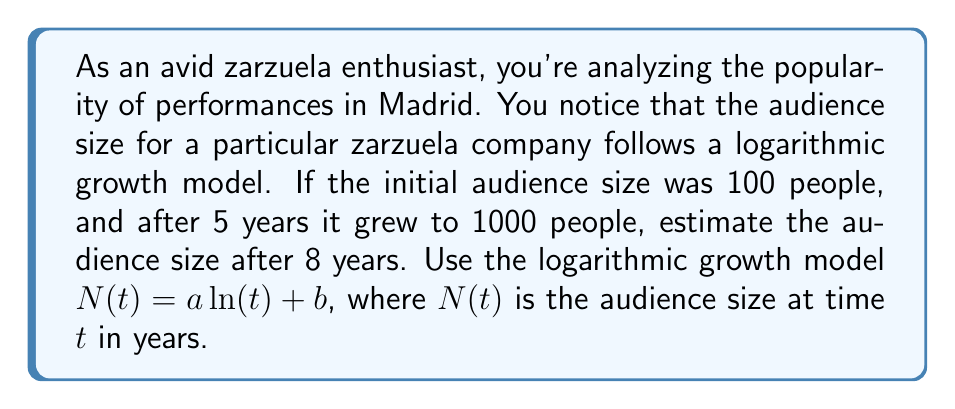Show me your answer to this math problem. Let's approach this step-by-step:

1) We're using the logarithmic growth model $N(t) = a \ln(t) + b$

2) We have two known points:
   At $t=1$, $N(1) = 100$ (initial audience)
   At $t=5$, $N(5) = 1000$

3) Let's substitute these into our equation:
   $100 = a \ln(1) + b$
   $1000 = a \ln(5) + b$

4) Since $\ln(1) = 0$, from the first equation we get:
   $b = 100$

5) Substituting this into the second equation:
   $1000 = a \ln(5) + 100$
   $900 = a \ln(5)$
   $a = \frac{900}{\ln(5)} \approx 559.6$

6) Now we have our complete model:
   $N(t) = 559.6 \ln(t) + 100$

7) To estimate the audience after 8 years, we substitute $t=8$:
   $N(8) = 559.6 \ln(8) + 100$
   $\approx 559.6 * 2.0794 + 100$
   $\approx 1263.6$

Therefore, after 8 years, we estimate the audience size to be approximately 1264 people.
Answer: 1264 people (rounded to the nearest whole number) 